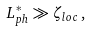<formula> <loc_0><loc_0><loc_500><loc_500>L _ { p h } ^ { * } \gg \zeta _ { l o c } \, ,</formula> 